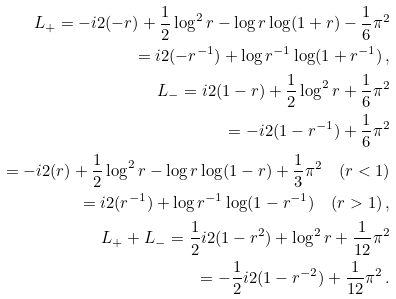Convert formula to latex. <formula><loc_0><loc_0><loc_500><loc_500>L _ { + } = - \L i 2 ( - r ) + \frac { 1 } { 2 } \log ^ { 2 } r - \log r \log ( 1 + r ) - \frac { 1 } { 6 } \pi ^ { 2 } \\ = \L i 2 ( - r ^ { - 1 } ) + \log r ^ { - 1 } \log ( 1 + r ^ { - 1 } ) \, , \\ L _ { - } = \L i 2 ( 1 - r ) + \frac { 1 } { 2 } \log ^ { 2 } r + \frac { 1 } { 6 } \pi ^ { 2 } \\ = - \L i 2 ( 1 - r ^ { - 1 } ) + \frac { 1 } { 6 } \pi ^ { 2 } \\ = - \L i 2 ( r ) + \frac { 1 } { 2 } \log ^ { 2 } r - \log r \log ( 1 - r ) + \frac { 1 } { 3 } \pi ^ { 2 } \quad ( r < 1 ) \\ = \L i 2 ( r ^ { - 1 } ) + \log r ^ { - 1 } \log ( 1 - r ^ { - 1 } ) \quad ( r > 1 ) \, , \\ L _ { + } + L _ { - } = \frac { 1 } { 2 } \L i 2 ( 1 - r ^ { 2 } ) + \log ^ { 2 } r + \frac { 1 } { 1 2 } \pi ^ { 2 } \\ = - \frac { 1 } { 2 } \L i 2 ( 1 - r ^ { - 2 } ) + \frac { 1 } { 1 2 } \pi ^ { 2 } \, .</formula> 